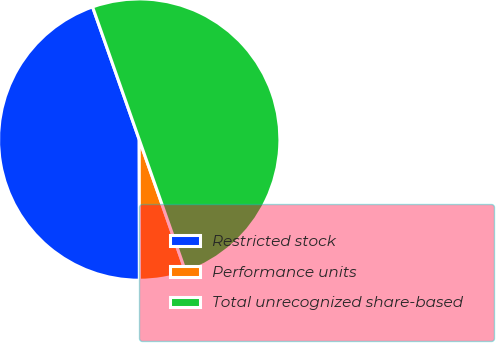<chart> <loc_0><loc_0><loc_500><loc_500><pie_chart><fcel>Restricted stock<fcel>Performance units<fcel>Total unrecognized share-based<nl><fcel>44.64%<fcel>5.36%<fcel>50.0%<nl></chart> 